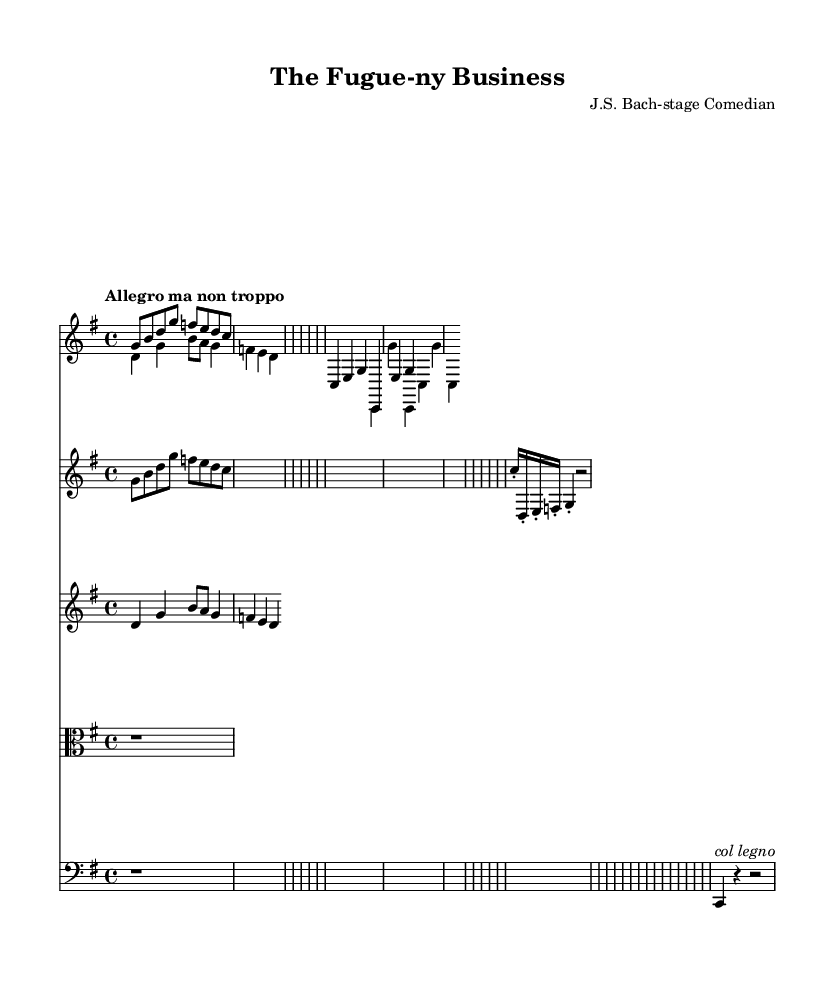What is the key signature of this music? The key signature shows one sharp, indicating that this piece is in G major.
Answer: G major What is the time signature of the piece? The time signature is noted at the beginning of the score and shows 4/4, meaning there are four beats in each measure.
Answer: 4/4 What is the tempo marking of the music? The tempo marking reads "Allegro ma non troppo," suggesting a lively pace, but not too fast.
Answer: Allegro ma non troppo How many voices are present in the harpsichord part? The harpsichord part contains two distinct voices clearly marked as upper and lower.
Answer: Two What is the dynamic marking at the beginning of the cello staff? The cello part does not have an explicit dynamic marking but includes a col legno instruction, which implies a specific way to play.
Answer: col legno Which instrument displays staccato notes in the first violin part? Staccato notes are indicated in the violin I staff, specifically on the 16th notes.
Answer: Violin I What type of music does this composition represent? This composition is representative of Baroque music, characterized by its complex textures and use of counterpoint.
Answer: Baroque 